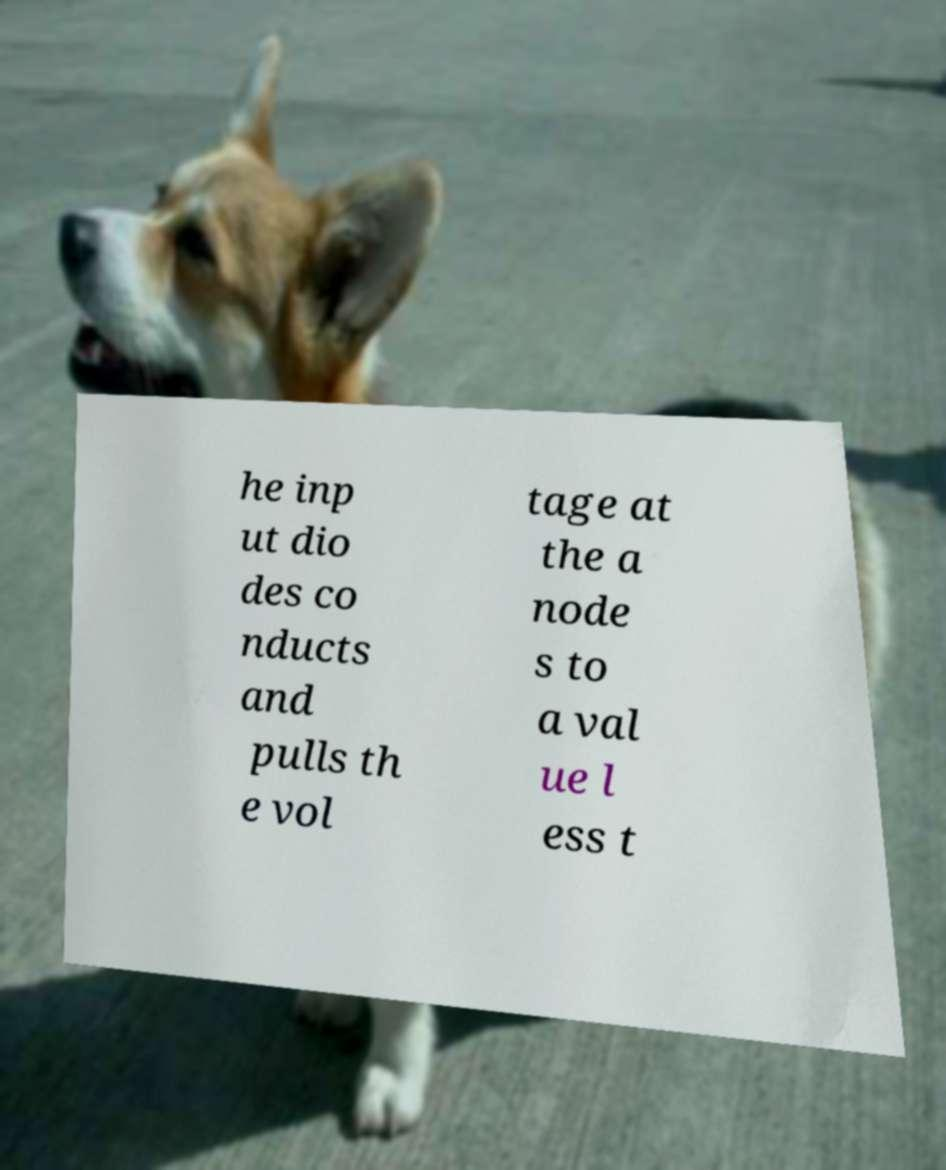Can you read and provide the text displayed in the image?This photo seems to have some interesting text. Can you extract and type it out for me? he inp ut dio des co nducts and pulls th e vol tage at the a node s to a val ue l ess t 